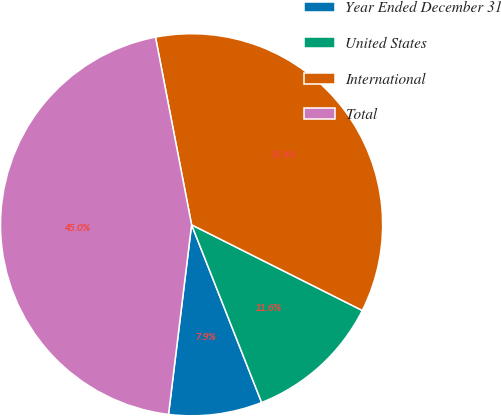Convert chart. <chart><loc_0><loc_0><loc_500><loc_500><pie_chart><fcel>Year Ended December 31<fcel>United States<fcel>International<fcel>Total<nl><fcel>7.9%<fcel>11.62%<fcel>35.43%<fcel>45.05%<nl></chart> 